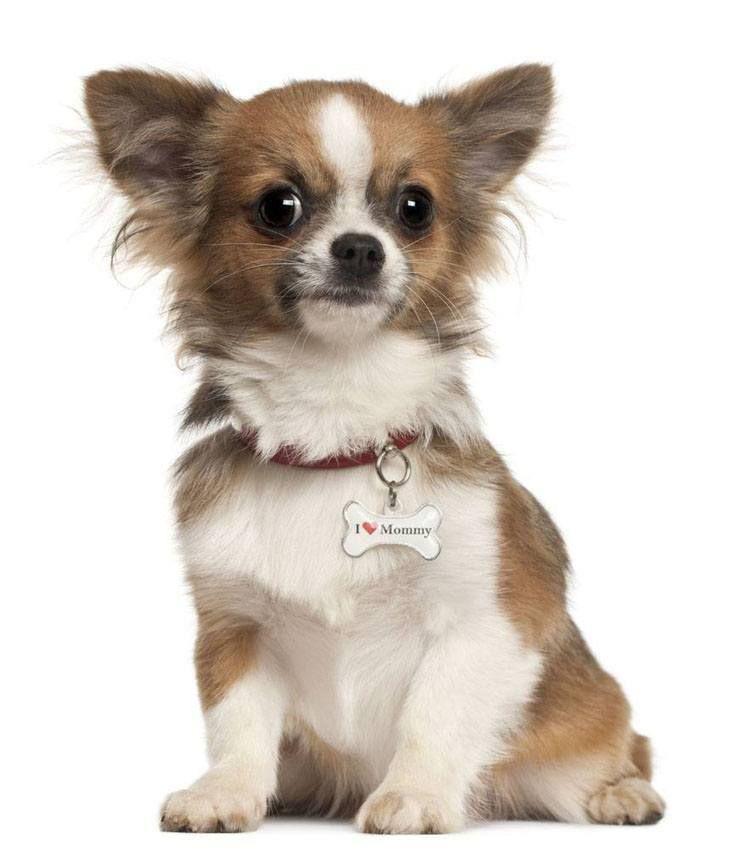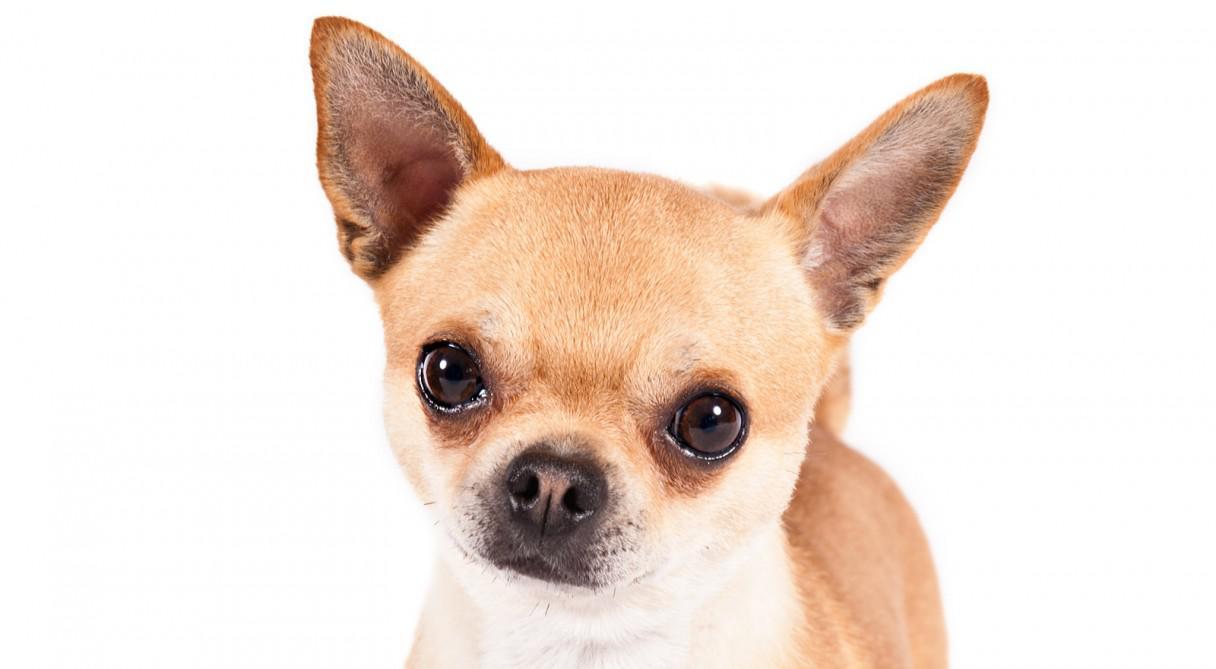The first image is the image on the left, the second image is the image on the right. Examine the images to the left and right. Is the description "There is a single dog in the image on the right." accurate? Answer yes or no. Yes. The first image is the image on the left, the second image is the image on the right. Given the left and right images, does the statement "The right image contains three chihuahua's." hold true? Answer yes or no. No. 